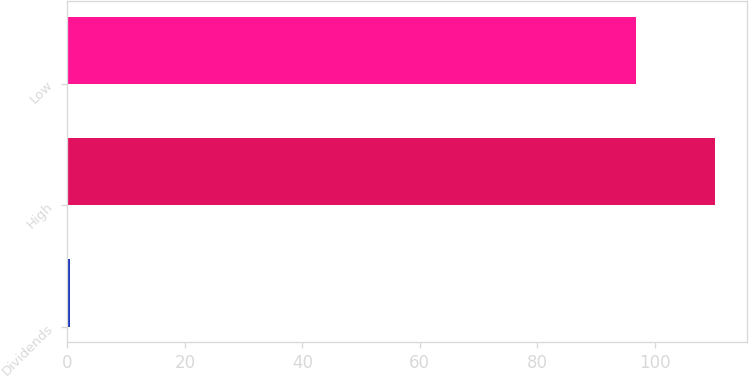Convert chart to OTSL. <chart><loc_0><loc_0><loc_500><loc_500><bar_chart><fcel>Dividends<fcel>High<fcel>Low<nl><fcel>0.5<fcel>110.26<fcel>96.76<nl></chart> 